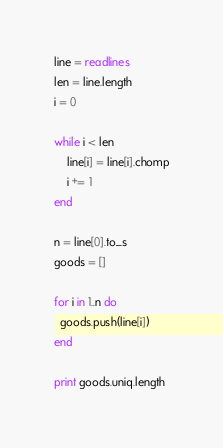Convert code to text. <code><loc_0><loc_0><loc_500><loc_500><_Ruby_>line = readlines
len = line.length
i = 0

while i < len
    line[i] = line[i].chomp
    i += 1
end

n = line[0].to_s
goods = []

for i in 1..n do
  goods.push(line[i])
end

print goods.uniq.length</code> 